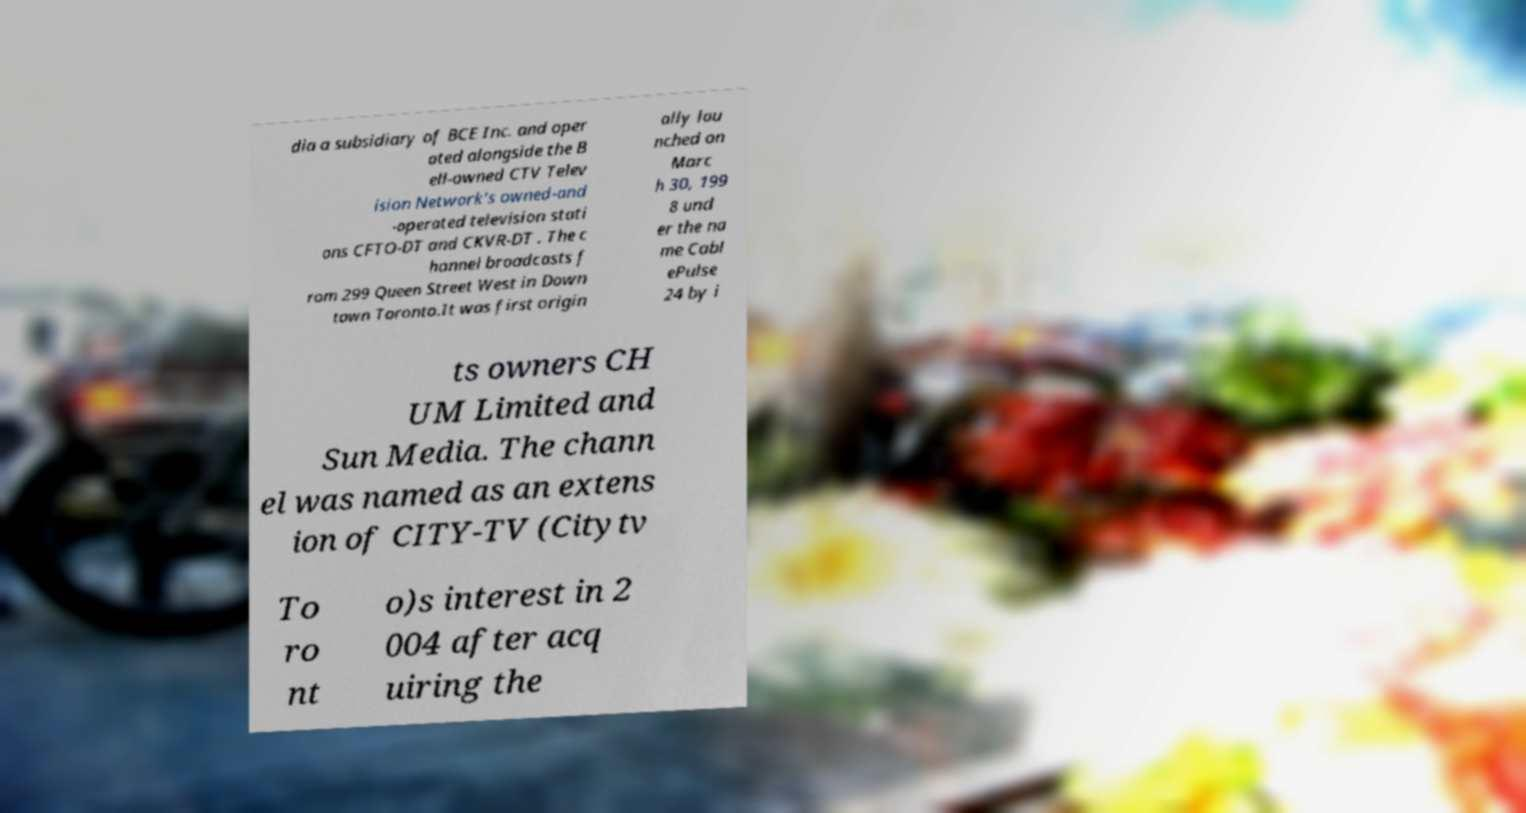I need the written content from this picture converted into text. Can you do that? dia a subsidiary of BCE Inc. and oper ated alongside the B ell-owned CTV Telev ision Network's owned-and -operated television stati ons CFTO-DT and CKVR-DT . The c hannel broadcasts f rom 299 Queen Street West in Down town Toronto.It was first origin ally lau nched on Marc h 30, 199 8 und er the na me Cabl ePulse 24 by i ts owners CH UM Limited and Sun Media. The chann el was named as an extens ion of CITY-TV (Citytv To ro nt o)s interest in 2 004 after acq uiring the 